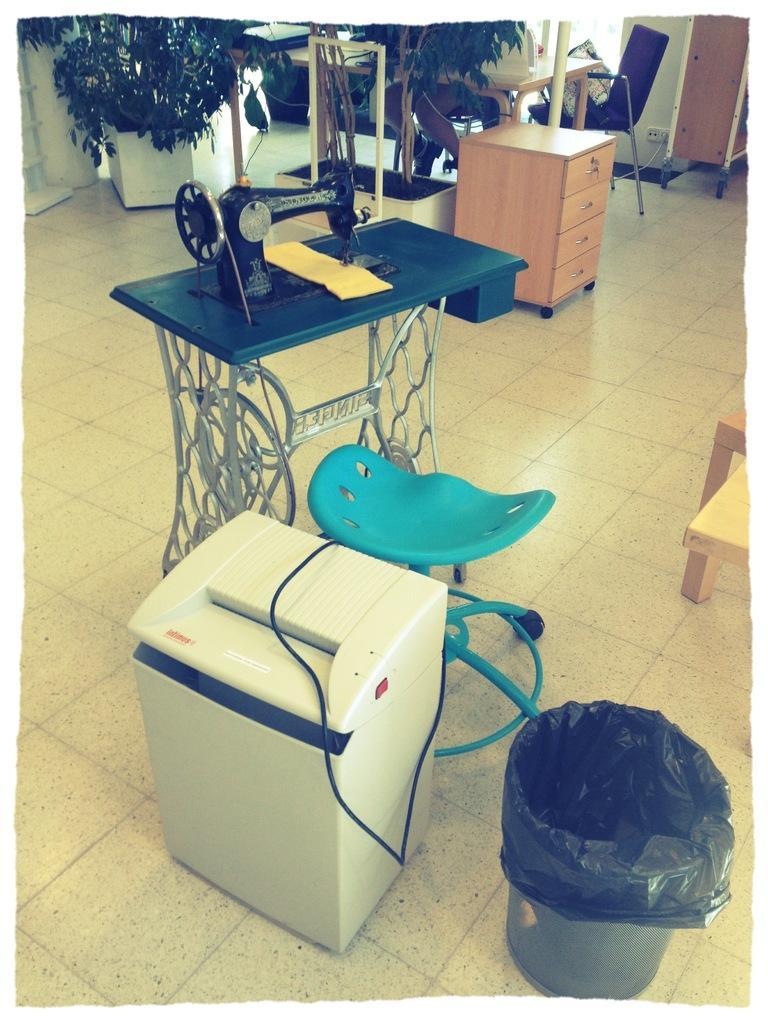Can you describe this image briefly? In this picture I can see plants in the pots and I can see a sewing machine and I can see a stool and I can see table and chairs and another table with drawers and I can see a dustbin and looks like a printer on the left side. 